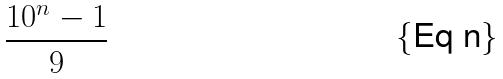<formula> <loc_0><loc_0><loc_500><loc_500>\frac { 1 0 ^ { n } - 1 } { 9 }</formula> 